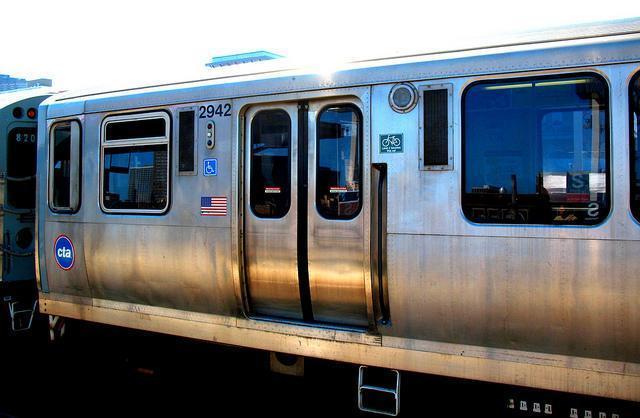How many umbrellas have more than 4 colors?
Give a very brief answer. 0. 